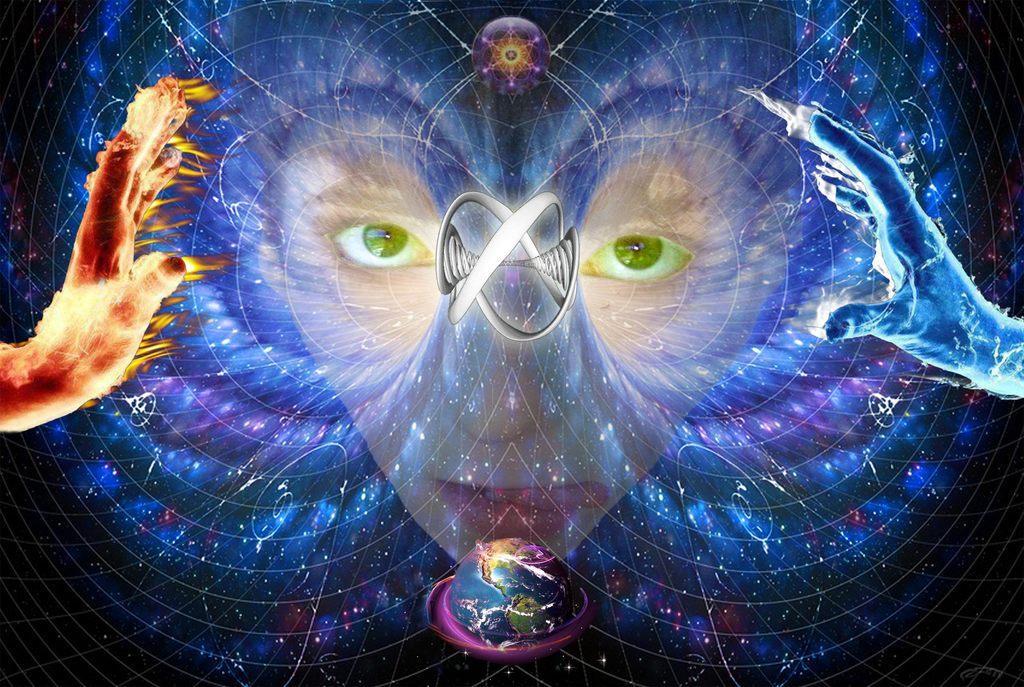Describe this image in one or two sentences. This is a picture of an animation, where we can see persons face, person's hands with fire, some illusion of water and the planet earth. 